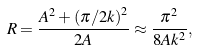Convert formula to latex. <formula><loc_0><loc_0><loc_500><loc_500>R = \frac { A ^ { 2 } + \left ( { \pi / 2 k } \right ) ^ { 2 } } { 2 A } \approx \frac { \pi ^ { 2 } } { 8 A k ^ { 2 } } ,</formula> 